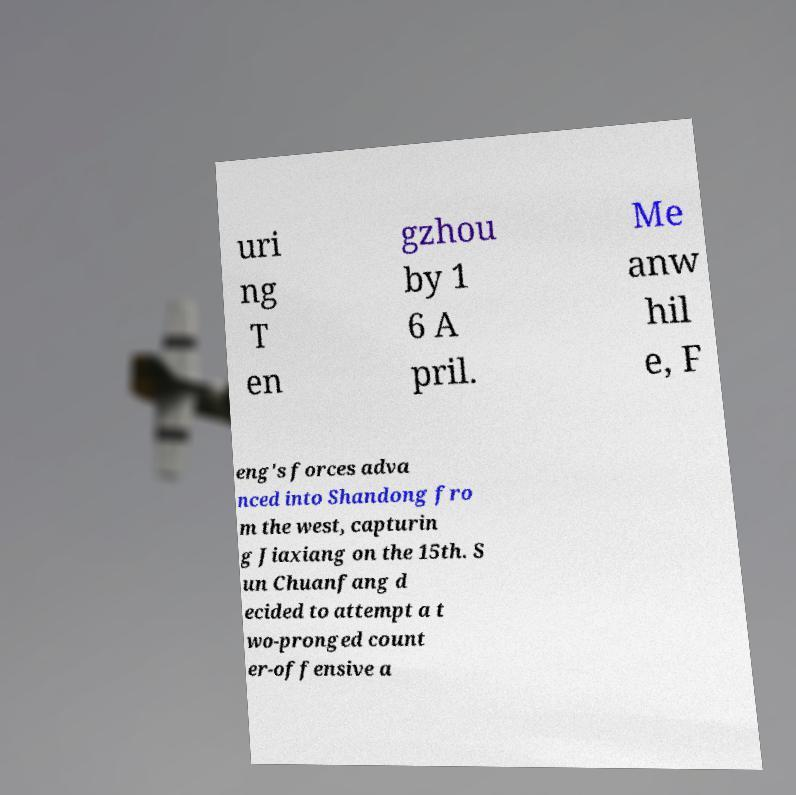Can you read and provide the text displayed in the image?This photo seems to have some interesting text. Can you extract and type it out for me? uri ng T en gzhou by 1 6 A pril. Me anw hil e, F eng's forces adva nced into Shandong fro m the west, capturin g Jiaxiang on the 15th. S un Chuanfang d ecided to attempt a t wo-pronged count er-offensive a 